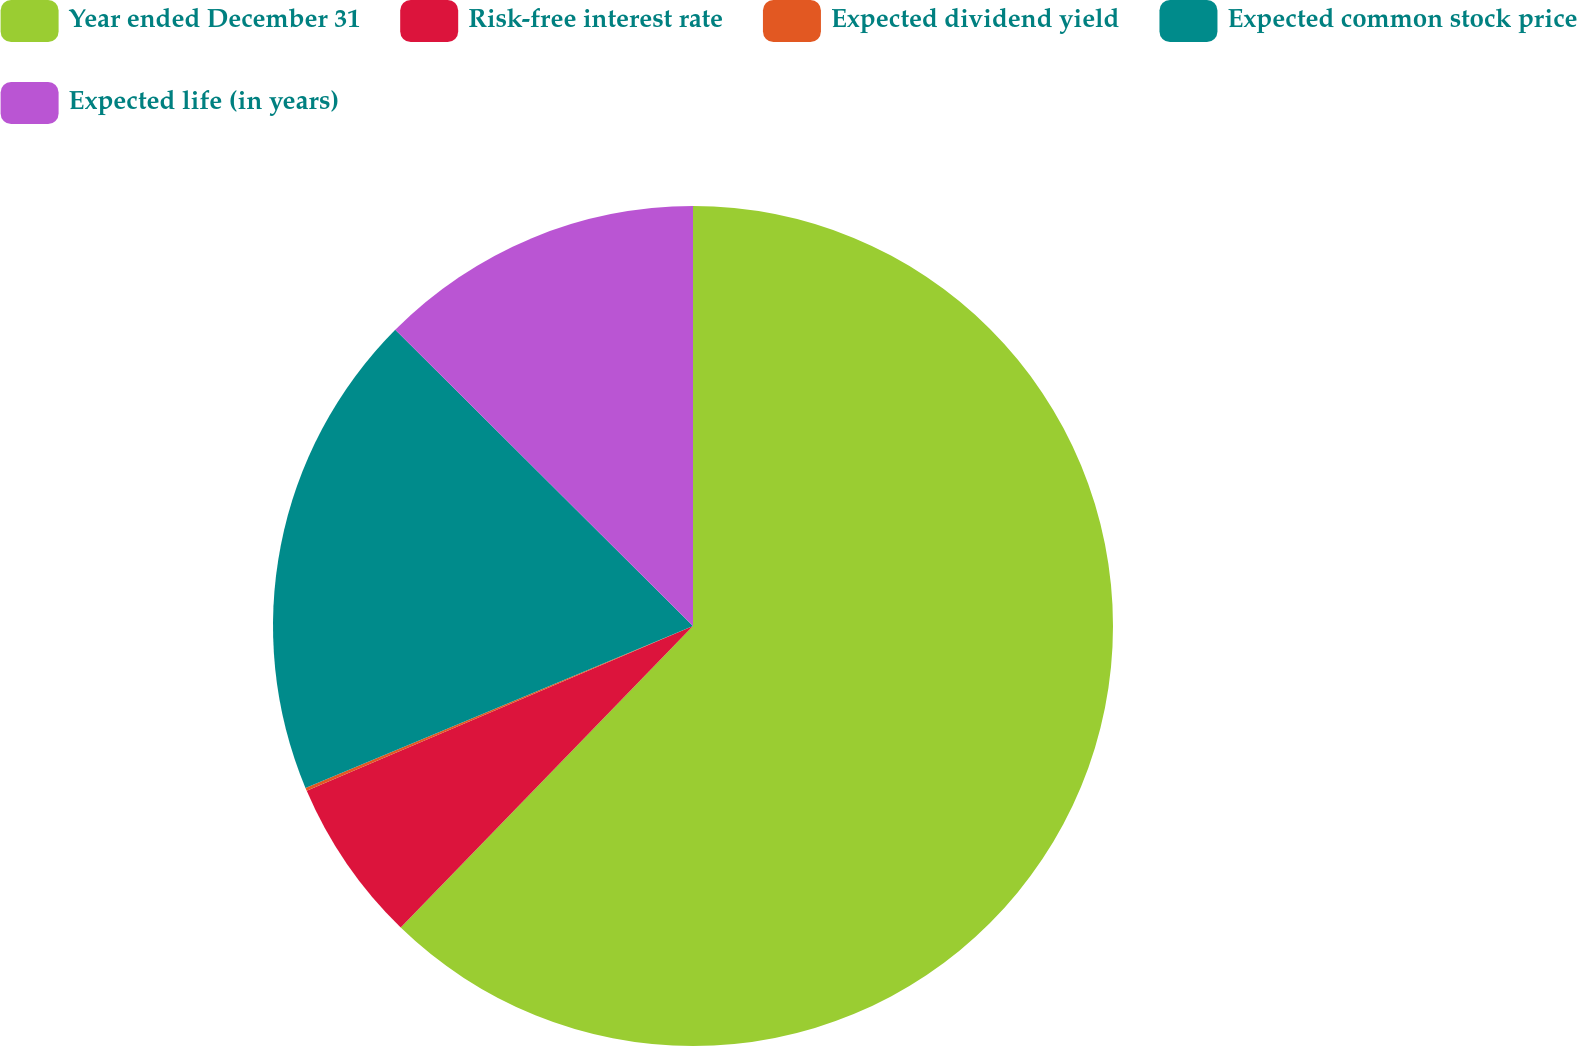Convert chart to OTSL. <chart><loc_0><loc_0><loc_500><loc_500><pie_chart><fcel>Year ended December 31<fcel>Risk-free interest rate<fcel>Expected dividend yield<fcel>Expected common stock price<fcel>Expected life (in years)<nl><fcel>62.25%<fcel>6.33%<fcel>0.12%<fcel>18.76%<fcel>12.54%<nl></chart> 